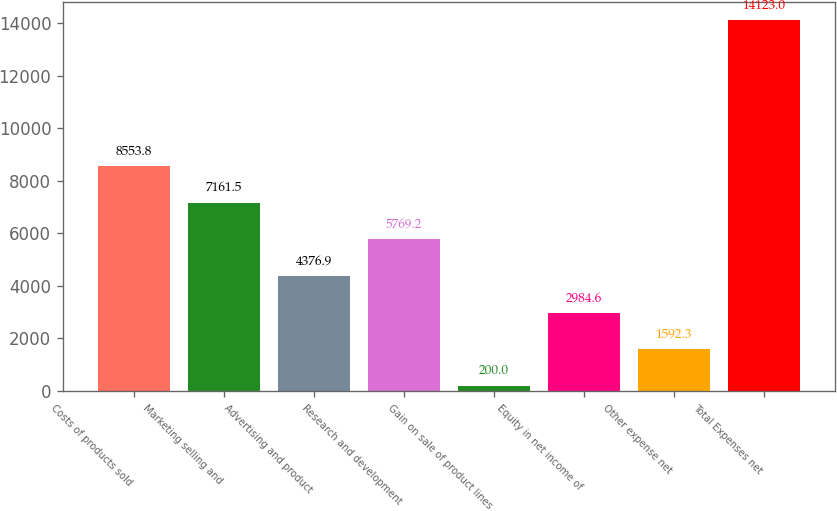<chart> <loc_0><loc_0><loc_500><loc_500><bar_chart><fcel>Costs of products sold<fcel>Marketing selling and<fcel>Advertising and product<fcel>Research and development<fcel>Gain on sale of product lines<fcel>Equity in net income of<fcel>Other expense net<fcel>Total Expenses net<nl><fcel>8553.8<fcel>7161.5<fcel>4376.9<fcel>5769.2<fcel>200<fcel>2984.6<fcel>1592.3<fcel>14123<nl></chart> 